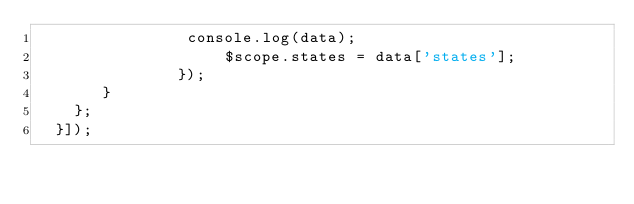<code> <loc_0><loc_0><loc_500><loc_500><_JavaScript_>      			console.log(data);
				    $scope.states = data['states'];
			   });
       }
    };
  }]);</code> 